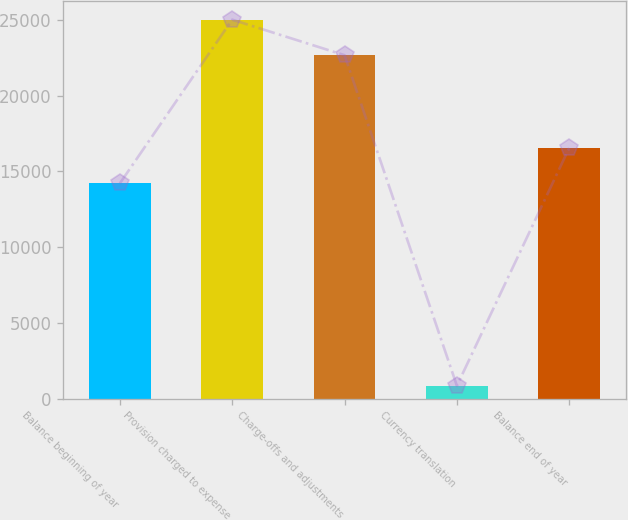Convert chart. <chart><loc_0><loc_0><loc_500><loc_500><bar_chart><fcel>Balance beginning of year<fcel>Provision charged to expense<fcel>Charge-offs and adjustments<fcel>Currency translation<fcel>Balance end of year<nl><fcel>14212<fcel>25030.4<fcel>22682<fcel>840<fcel>16560.4<nl></chart> 